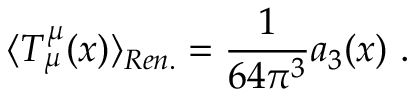<formula> <loc_0><loc_0><loc_500><loc_500>\langle T _ { \mu } ^ { \mu } ( x ) \rangle _ { R e n . } = \frac { 1 } 6 4 \pi ^ { 3 } } a _ { 3 } ( x ) \ .</formula> 